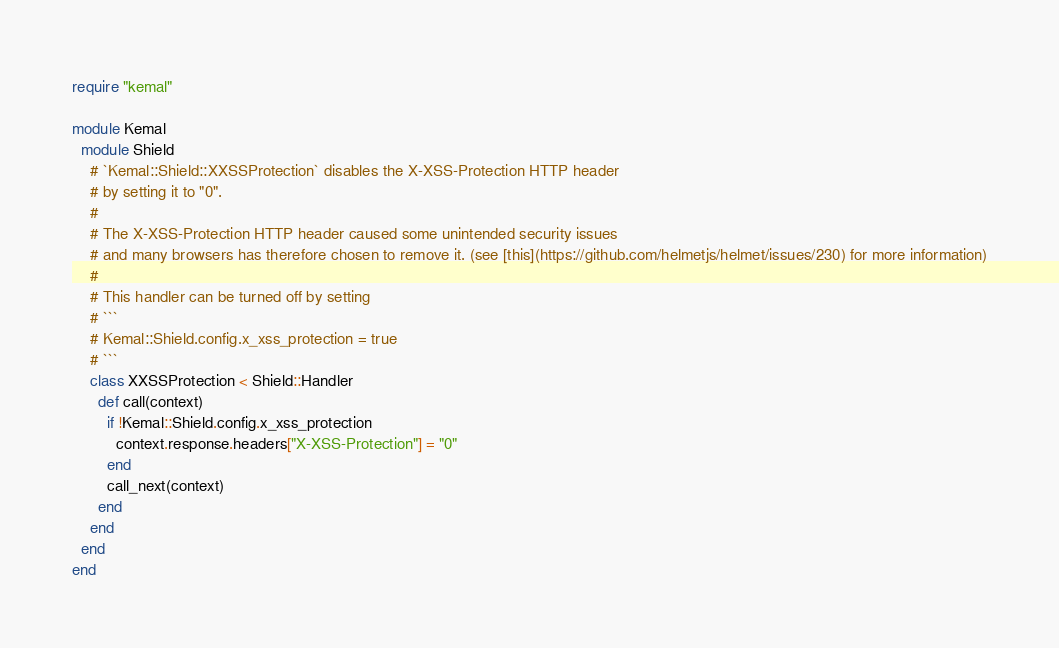<code> <loc_0><loc_0><loc_500><loc_500><_Crystal_>require "kemal"

module Kemal
  module Shield
    # `Kemal::Shield::XXSSProtection` disables the X-XSS-Protection HTTP header
    # by setting it to "0".
    #
    # The X-XSS-Protection HTTP header caused some unintended security issues
    # and many browsers has therefore chosen to remove it. (see [this](https://github.com/helmetjs/helmet/issues/230) for more information)
    #
    # This handler can be turned off by setting
    # ```
    # Kemal::Shield.config.x_xss_protection = true
    # ```
    class XXSSProtection < Shield::Handler
      def call(context)
        if !Kemal::Shield.config.x_xss_protection
          context.response.headers["X-XSS-Protection"] = "0"
        end
        call_next(context)
      end
    end
  end
end
</code> 